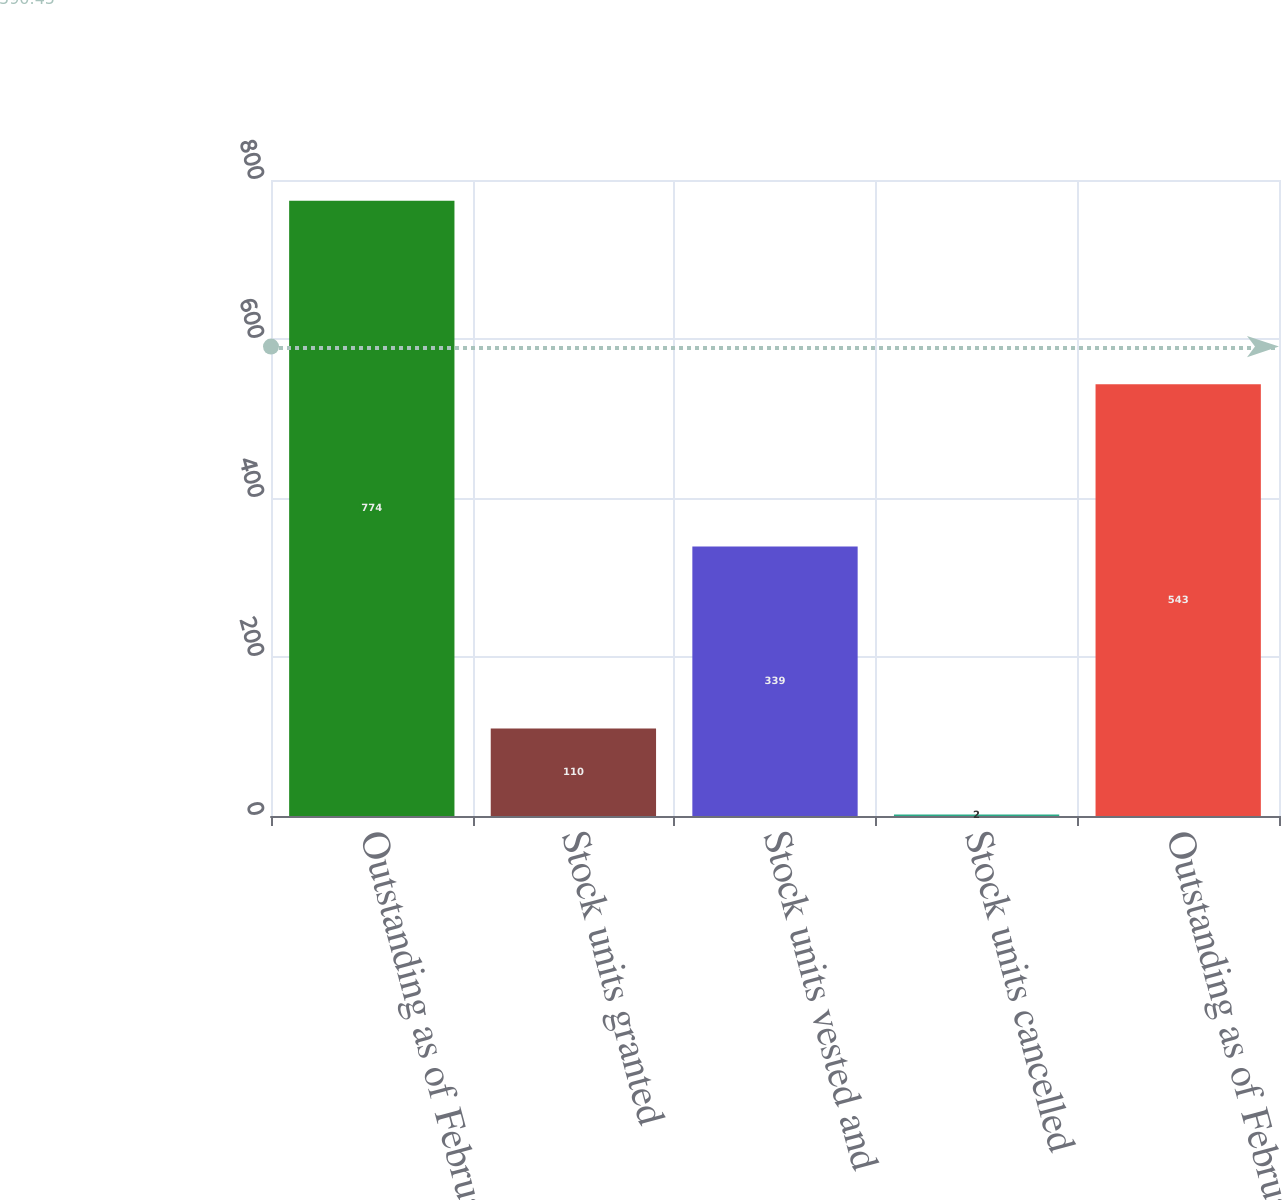Convert chart. <chart><loc_0><loc_0><loc_500><loc_500><bar_chart><fcel>Outstanding as of February 28<fcel>Stock units granted<fcel>Stock units vested and<fcel>Stock units cancelled<fcel>Outstanding as of February 29<nl><fcel>774<fcel>110<fcel>339<fcel>2<fcel>543<nl></chart> 